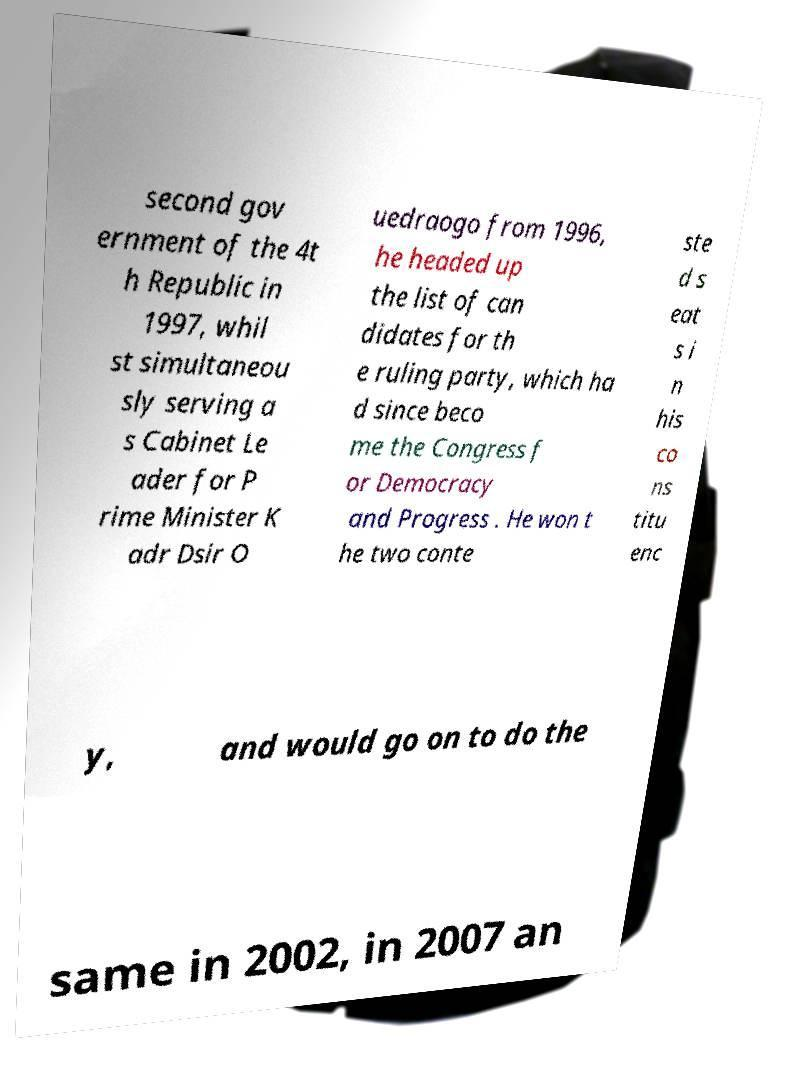Can you accurately transcribe the text from the provided image for me? second gov ernment of the 4t h Republic in 1997, whil st simultaneou sly serving a s Cabinet Le ader for P rime Minister K adr Dsir O uedraogo from 1996, he headed up the list of can didates for th e ruling party, which ha d since beco me the Congress f or Democracy and Progress . He won t he two conte ste d s eat s i n his co ns titu enc y, and would go on to do the same in 2002, in 2007 an 